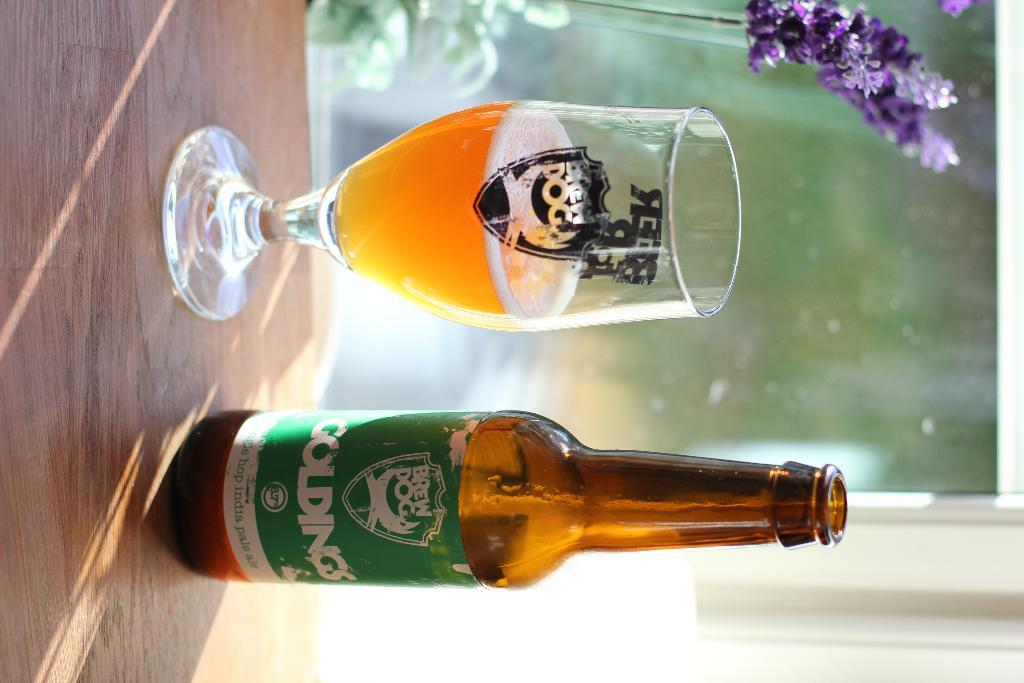<image>
Share a concise interpretation of the image provided. A bottle of Goldings next to a wine glass that says blue dog. 